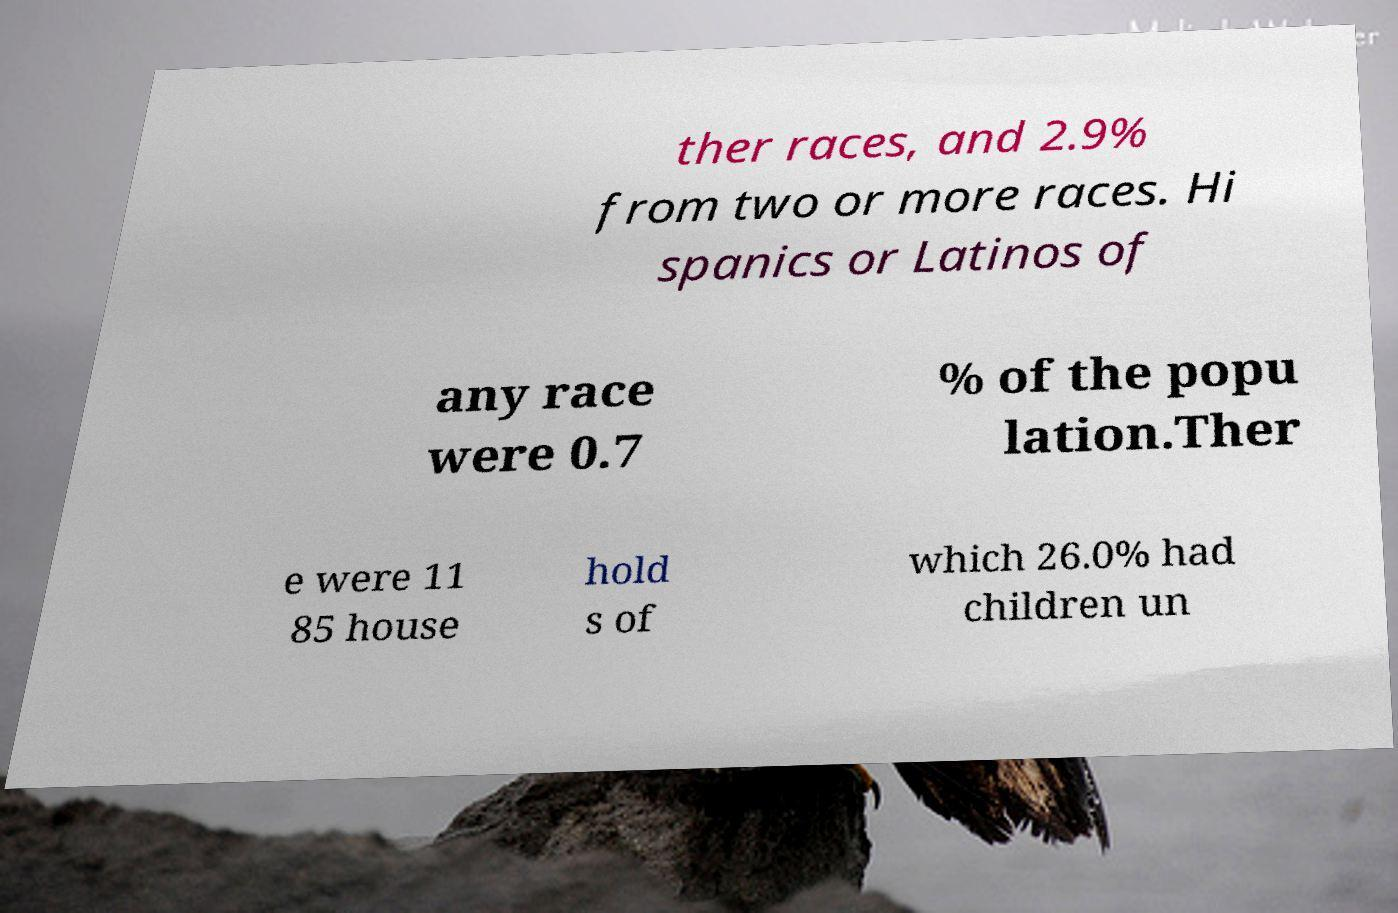I need the written content from this picture converted into text. Can you do that? ther races, and 2.9% from two or more races. Hi spanics or Latinos of any race were 0.7 % of the popu lation.Ther e were 11 85 house hold s of which 26.0% had children un 